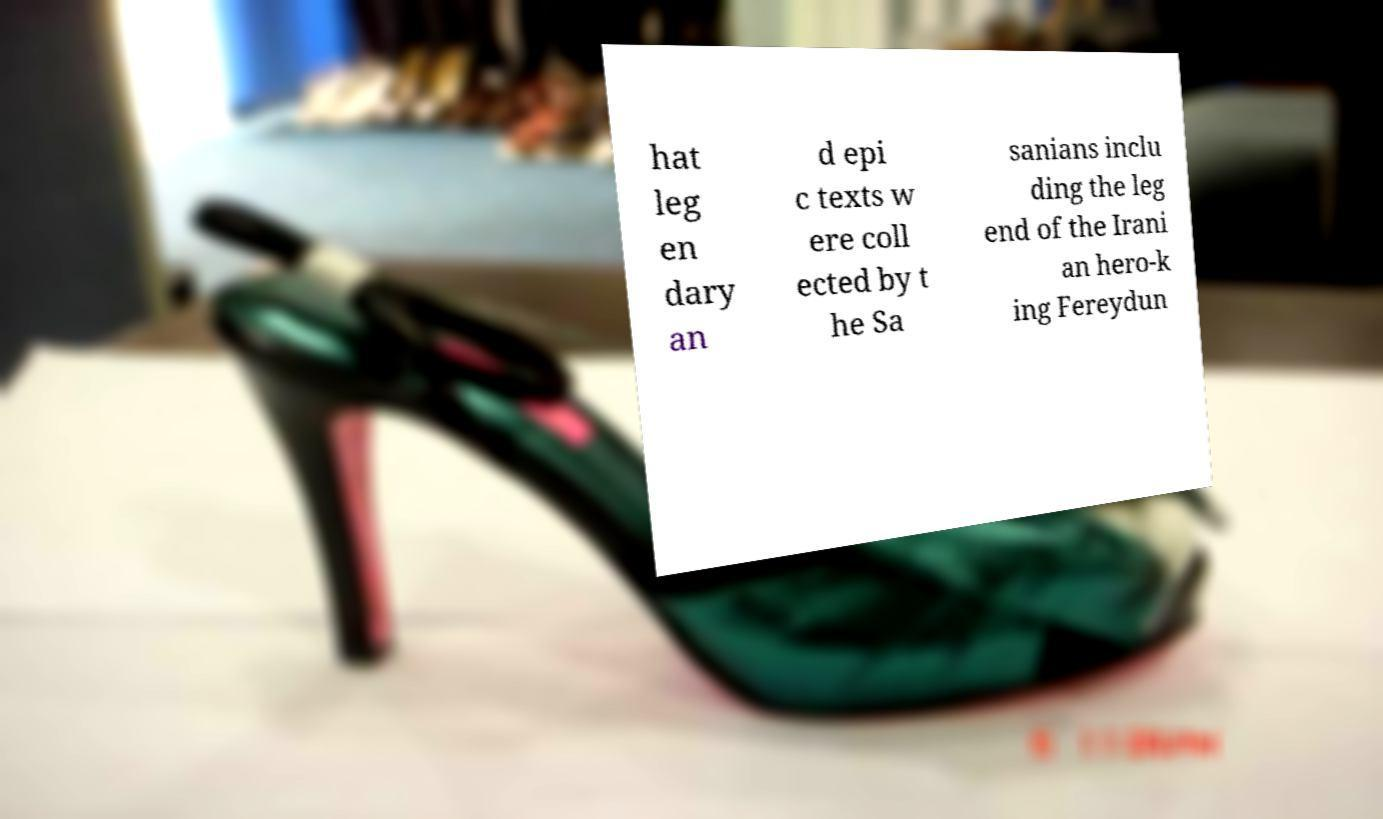Can you accurately transcribe the text from the provided image for me? hat leg en dary an d epi c texts w ere coll ected by t he Sa sanians inclu ding the leg end of the Irani an hero-k ing Fereydun 